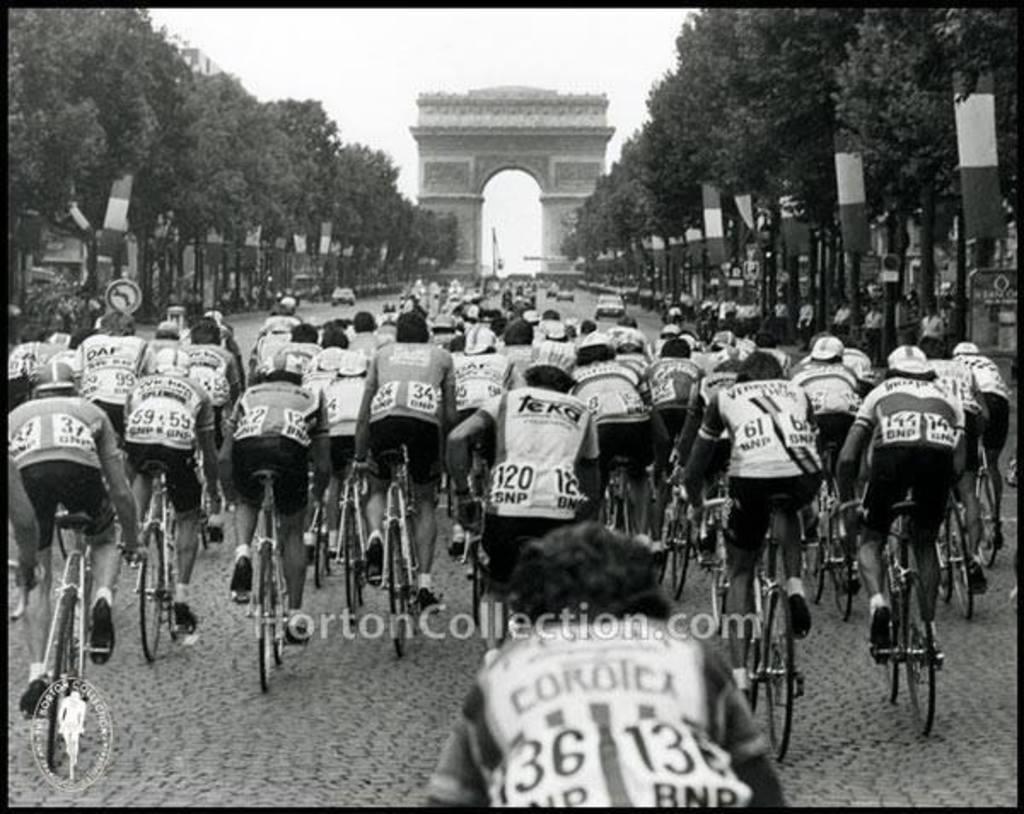Can you describe this image briefly? There are group of riders riding bicycle and there are trees on the either side of the road and there is a arch in front of them. 